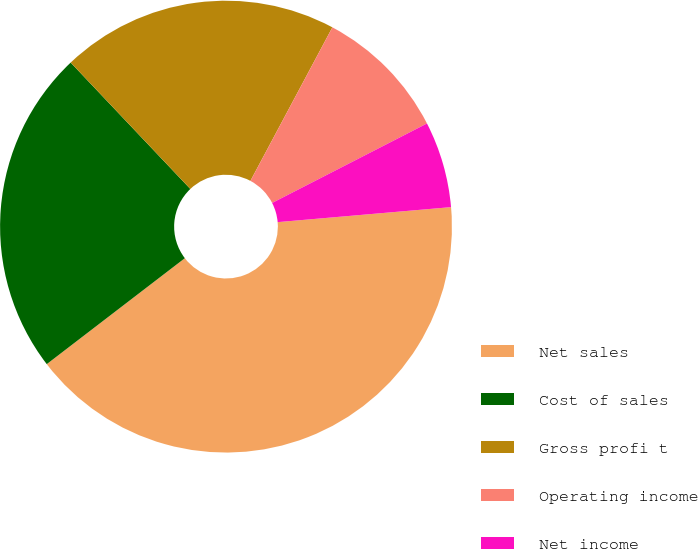Convert chart to OTSL. <chart><loc_0><loc_0><loc_500><loc_500><pie_chart><fcel>Net sales<fcel>Cost of sales<fcel>Gross profi t<fcel>Operating income<fcel>Net income<nl><fcel>40.96%<fcel>23.35%<fcel>19.87%<fcel>9.65%<fcel>6.17%<nl></chart> 